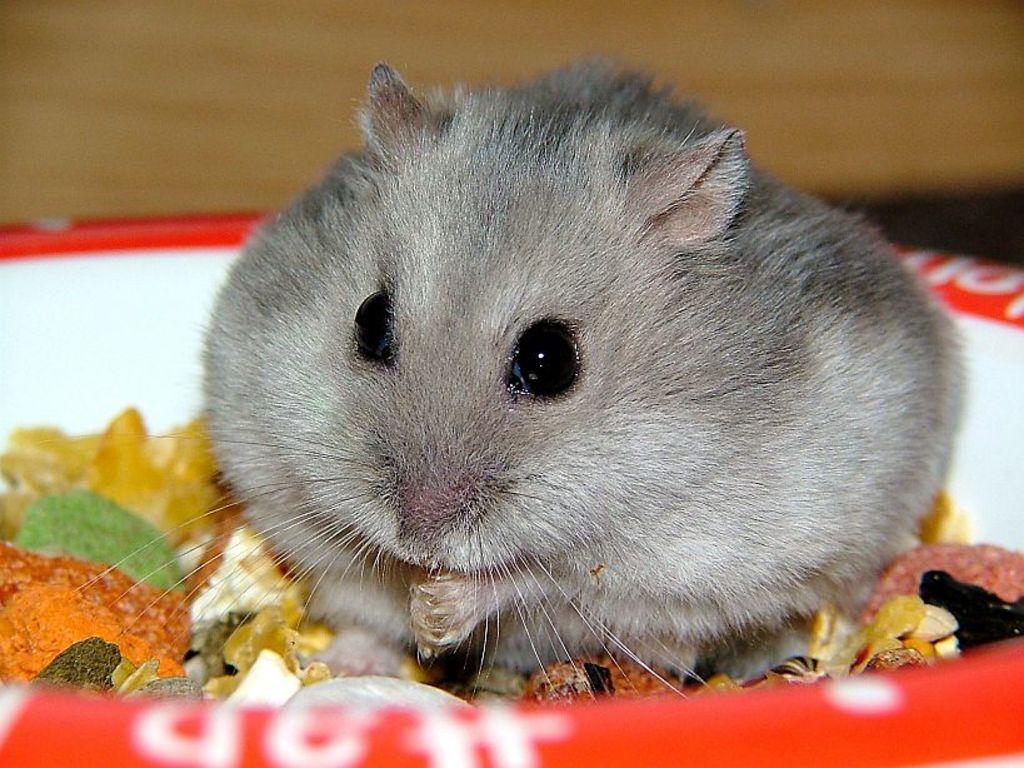Describe this image in one or two sentences. In the foreground of this picture, there is a rat in a bowl which is having food in it. In the background, there is a wall. 